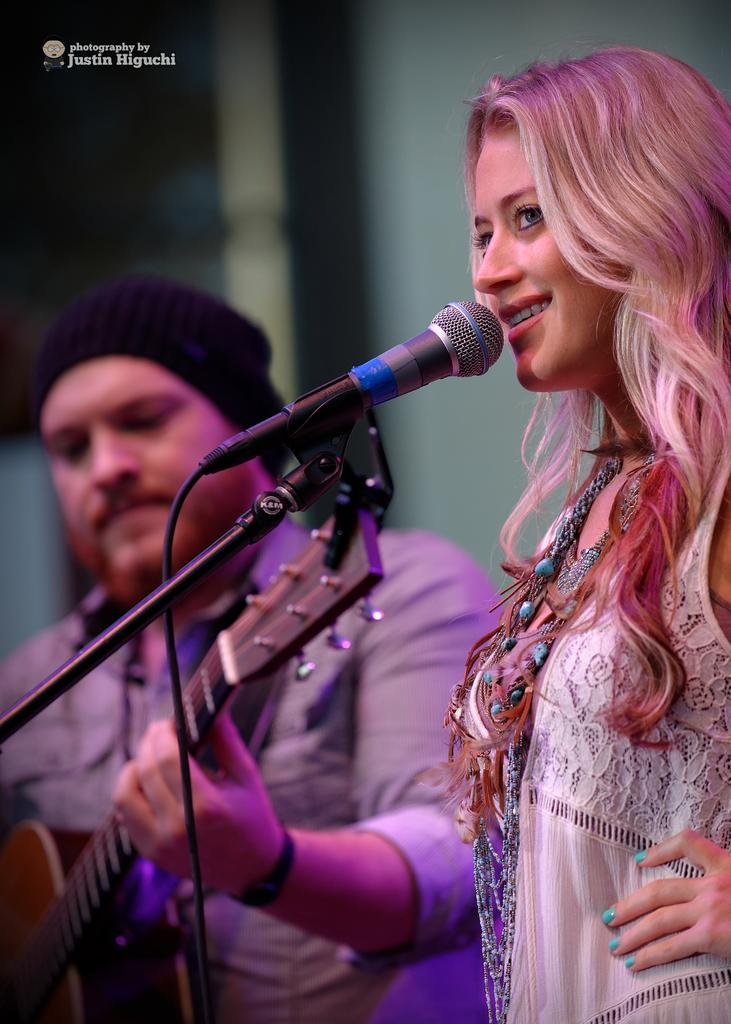Who is present in the image? There is a woman and a man in the image. What is the woman doing in the image? The woman is smiling in the image. What object is in front of the woman? There is a microphone in front of the woman. What is the man wearing in the image? The man is wearing a guitar in the image. What is the man doing with the guitar? The man's hand is on the guitar in the image. What can be seen in the background of the image? There is a wall in the background of the image, and it is blurry. What type of poison is the woman holding in the image? There is no poison present in the image; the woman is holding a microphone. What color is the cap that the man is wearing with the guitar? The man is not wearing a cap in the image; he is wearing a guitar. 